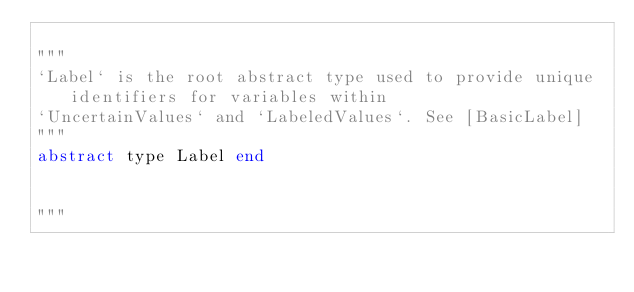<code> <loc_0><loc_0><loc_500><loc_500><_Julia_>
"""
`Label` is the root abstract type used to provide unique identifiers for variables within
`UncertainValues` and `LabeledValues`. See [BasicLabel]
"""
abstract type Label end


"""</code> 